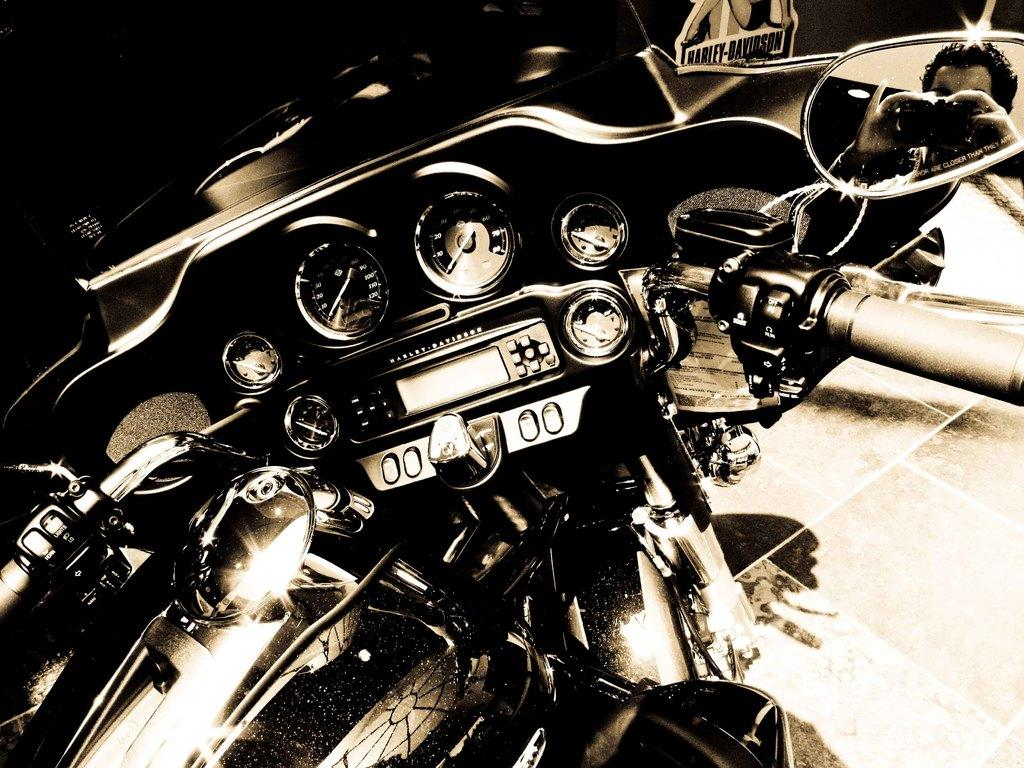What is the main object in the image? There is a bike in the image. What can be seen on the right side of the image? There is a mirror on the right side of the image. Who or what is visible in the mirror? A person is visible in the mirror. How is the image presented in terms of color? The image is black and white. How many kittens are sitting on the tongue of the person in the mirror? There are no kittens present in the image, and the person's tongue is not visible. 